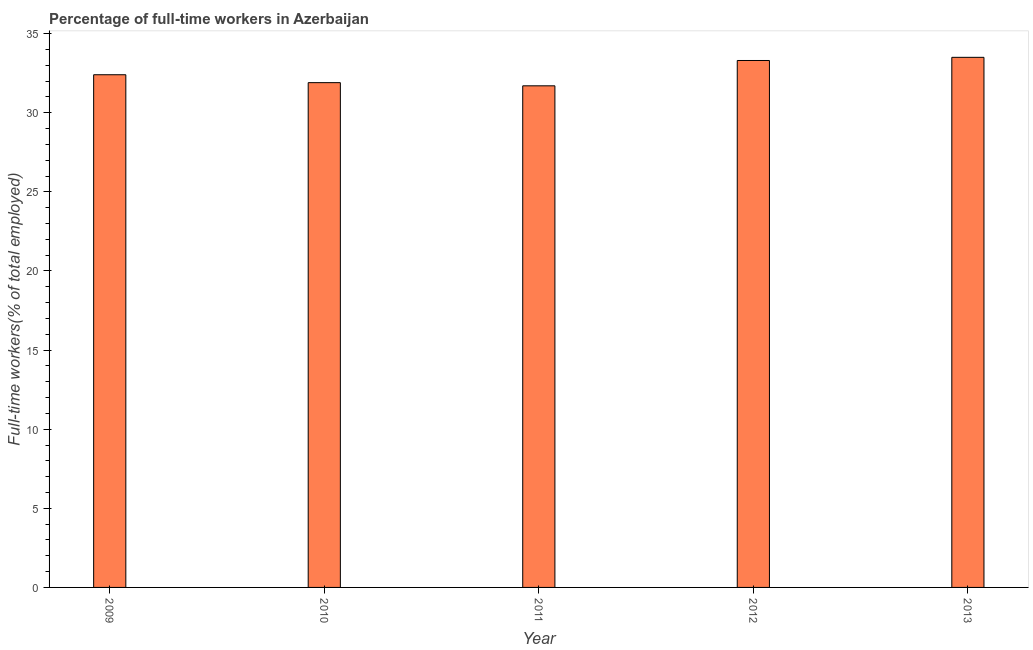Does the graph contain any zero values?
Offer a terse response. No. Does the graph contain grids?
Give a very brief answer. No. What is the title of the graph?
Your response must be concise. Percentage of full-time workers in Azerbaijan. What is the label or title of the Y-axis?
Give a very brief answer. Full-time workers(% of total employed). What is the percentage of full-time workers in 2012?
Provide a succinct answer. 33.3. Across all years, what is the maximum percentage of full-time workers?
Provide a succinct answer. 33.5. Across all years, what is the minimum percentage of full-time workers?
Make the answer very short. 31.7. In which year was the percentage of full-time workers maximum?
Your answer should be compact. 2013. What is the sum of the percentage of full-time workers?
Your answer should be very brief. 162.8. What is the difference between the percentage of full-time workers in 2010 and 2013?
Give a very brief answer. -1.6. What is the average percentage of full-time workers per year?
Provide a short and direct response. 32.56. What is the median percentage of full-time workers?
Provide a succinct answer. 32.4. Do a majority of the years between 2009 and 2011 (inclusive) have percentage of full-time workers greater than 17 %?
Make the answer very short. Yes. Is the difference between the percentage of full-time workers in 2012 and 2013 greater than the difference between any two years?
Offer a terse response. No. What is the difference between the highest and the second highest percentage of full-time workers?
Offer a very short reply. 0.2. How many bars are there?
Offer a very short reply. 5. What is the difference between two consecutive major ticks on the Y-axis?
Offer a very short reply. 5. Are the values on the major ticks of Y-axis written in scientific E-notation?
Keep it short and to the point. No. What is the Full-time workers(% of total employed) of 2009?
Your answer should be very brief. 32.4. What is the Full-time workers(% of total employed) of 2010?
Make the answer very short. 31.9. What is the Full-time workers(% of total employed) of 2011?
Make the answer very short. 31.7. What is the Full-time workers(% of total employed) of 2012?
Provide a succinct answer. 33.3. What is the Full-time workers(% of total employed) of 2013?
Keep it short and to the point. 33.5. What is the difference between the Full-time workers(% of total employed) in 2009 and 2011?
Provide a short and direct response. 0.7. What is the difference between the Full-time workers(% of total employed) in 2009 and 2012?
Make the answer very short. -0.9. What is the difference between the Full-time workers(% of total employed) in 2009 and 2013?
Your answer should be compact. -1.1. What is the difference between the Full-time workers(% of total employed) in 2010 and 2013?
Give a very brief answer. -1.6. What is the difference between the Full-time workers(% of total employed) in 2011 and 2012?
Offer a terse response. -1.6. What is the ratio of the Full-time workers(% of total employed) in 2009 to that in 2013?
Make the answer very short. 0.97. What is the ratio of the Full-time workers(% of total employed) in 2010 to that in 2011?
Make the answer very short. 1.01. What is the ratio of the Full-time workers(% of total employed) in 2010 to that in 2012?
Provide a succinct answer. 0.96. What is the ratio of the Full-time workers(% of total employed) in 2011 to that in 2013?
Ensure brevity in your answer.  0.95. What is the ratio of the Full-time workers(% of total employed) in 2012 to that in 2013?
Provide a short and direct response. 0.99. 